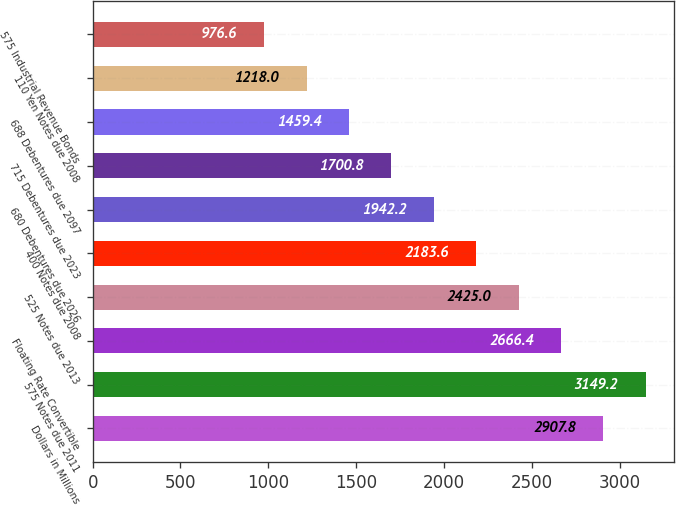Convert chart. <chart><loc_0><loc_0><loc_500><loc_500><bar_chart><fcel>Dollars in Millions<fcel>575 Notes due 2011<fcel>Floating Rate Convertible<fcel>525 Notes due 2013<fcel>400 Notes due 2008<fcel>680 Debentures due 2026<fcel>715 Debentures due 2023<fcel>688 Debentures due 2097<fcel>110 Yen Notes due 2008<fcel>575 Industrial Revenue Bonds<nl><fcel>2907.8<fcel>3149.2<fcel>2666.4<fcel>2425<fcel>2183.6<fcel>1942.2<fcel>1700.8<fcel>1459.4<fcel>1218<fcel>976.6<nl></chart> 